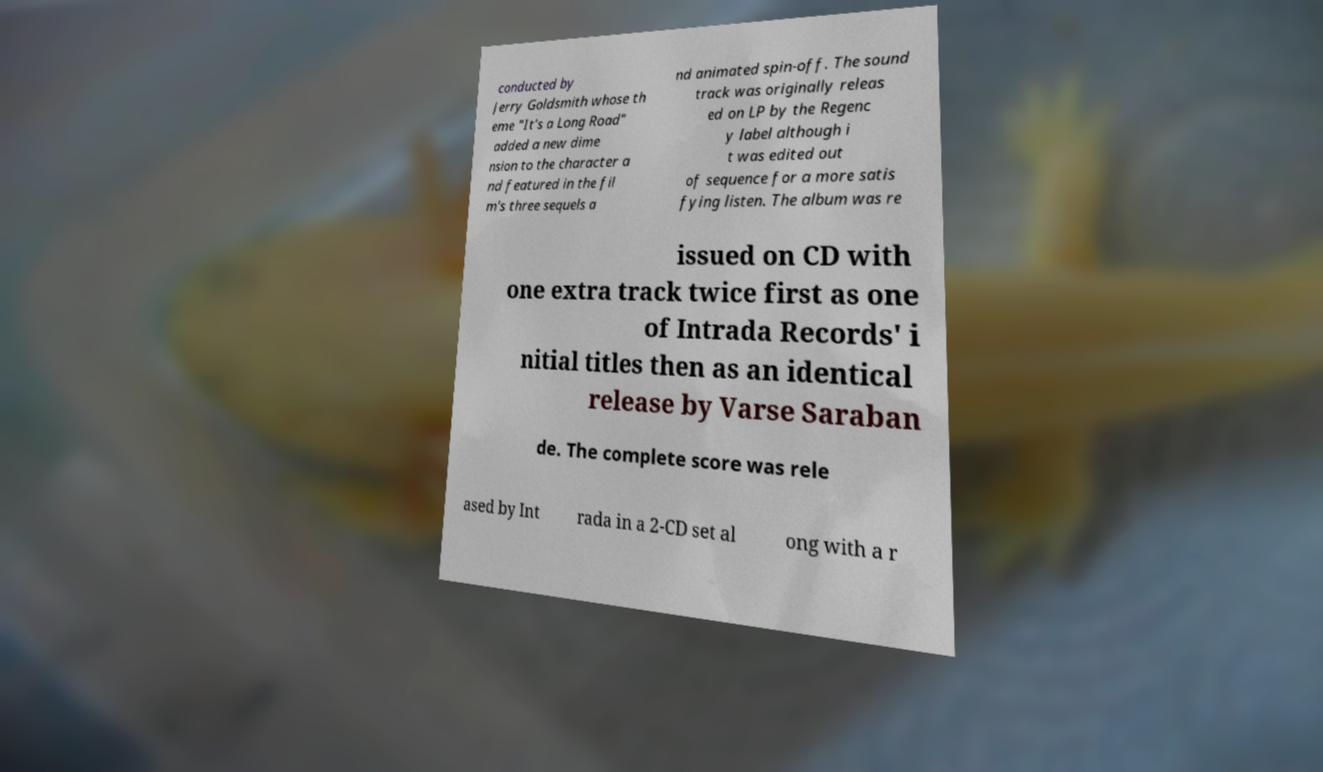Could you assist in decoding the text presented in this image and type it out clearly? conducted by Jerry Goldsmith whose th eme "It's a Long Road" added a new dime nsion to the character a nd featured in the fil m's three sequels a nd animated spin-off. The sound track was originally releas ed on LP by the Regenc y label although i t was edited out of sequence for a more satis fying listen. The album was re issued on CD with one extra track twice first as one of Intrada Records' i nitial titles then as an identical release by Varse Saraban de. The complete score was rele ased by Int rada in a 2-CD set al ong with a r 